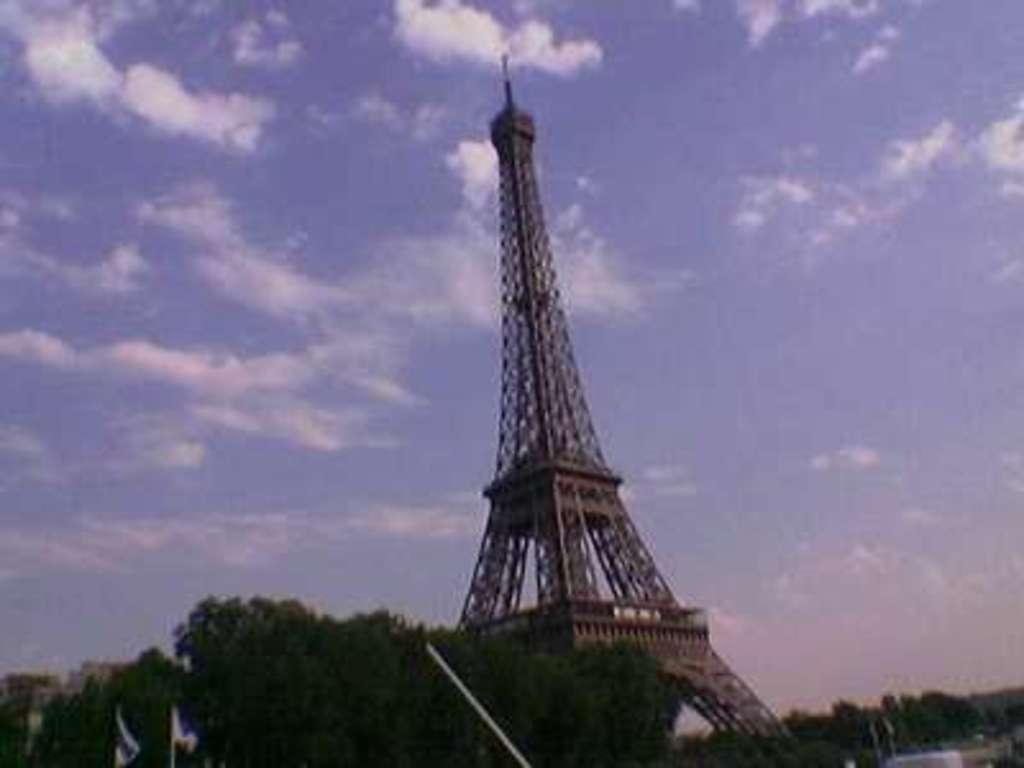How would you summarize this image in a sentence or two? in this image there is an Eiffel tower in the middle. At the top there is sky with the clouds. On the left side there are trees beside the tower. 